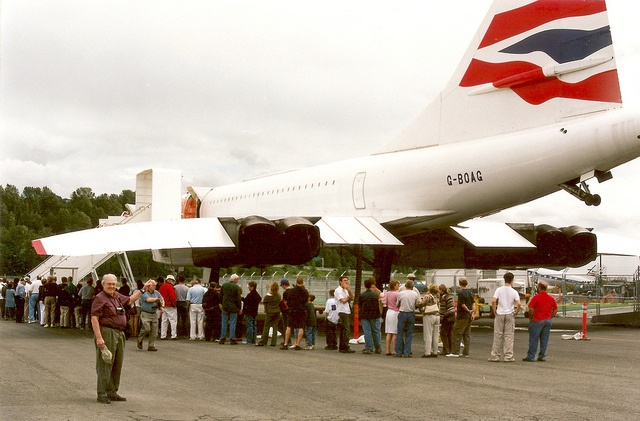Describe the objects in this image and their specific colors. I can see airplane in ivory, white, black, brown, and gray tones, people in ivory, black, gray, olive, and maroon tones, people in ivory, maroon, black, olive, and brown tones, people in ivory, lightgray, gray, and tan tones, and people in ivory, brown, black, maroon, and gray tones in this image. 